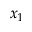<formula> <loc_0><loc_0><loc_500><loc_500>x _ { 1 }</formula> 